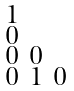Convert formula to latex. <formula><loc_0><loc_0><loc_500><loc_500>\begin{smallmatrix} 1 & & & \\ 0 & & & \\ 0 & 0 & & \\ 0 & 1 & 0 & \end{smallmatrix}</formula> 